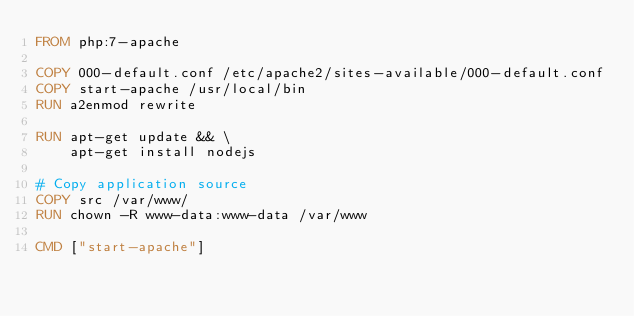Convert code to text. <code><loc_0><loc_0><loc_500><loc_500><_Dockerfile_>FROM php:7-apache

COPY 000-default.conf /etc/apache2/sites-available/000-default.conf
COPY start-apache /usr/local/bin
RUN a2enmod rewrite

RUN apt-get update && \
    apt-get install nodejs

# Copy application source
COPY src /var/www/
RUN chown -R www-data:www-data /var/www

CMD ["start-apache"]</code> 